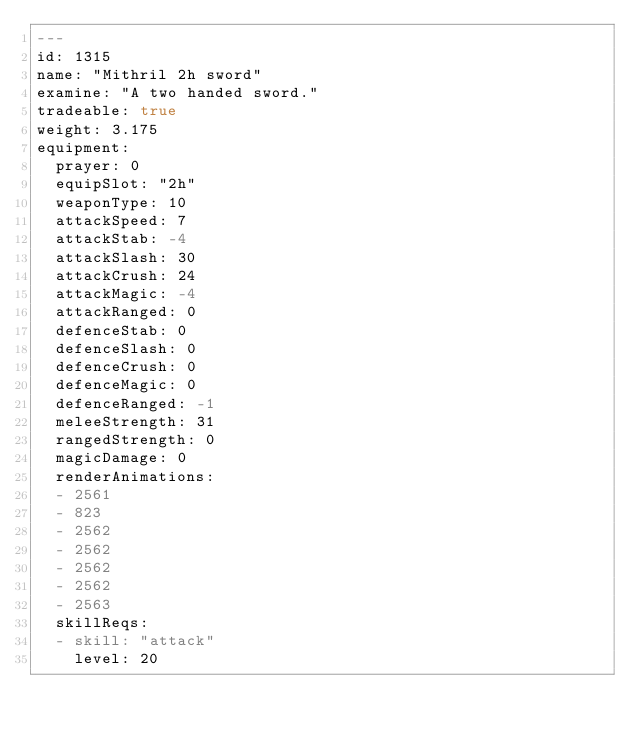Convert code to text. <code><loc_0><loc_0><loc_500><loc_500><_YAML_>---
id: 1315
name: "Mithril 2h sword"
examine: "A two handed sword."
tradeable: true
weight: 3.175
equipment:
  prayer: 0
  equipSlot: "2h"
  weaponType: 10
  attackSpeed: 7
  attackStab: -4
  attackSlash: 30
  attackCrush: 24
  attackMagic: -4
  attackRanged: 0
  defenceStab: 0
  defenceSlash: 0
  defenceCrush: 0
  defenceMagic: 0
  defenceRanged: -1
  meleeStrength: 31
  rangedStrength: 0
  magicDamage: 0
  renderAnimations:
  - 2561
  - 823
  - 2562
  - 2562
  - 2562
  - 2562
  - 2563
  skillReqs:
  - skill: "attack"
    level: 20
</code> 